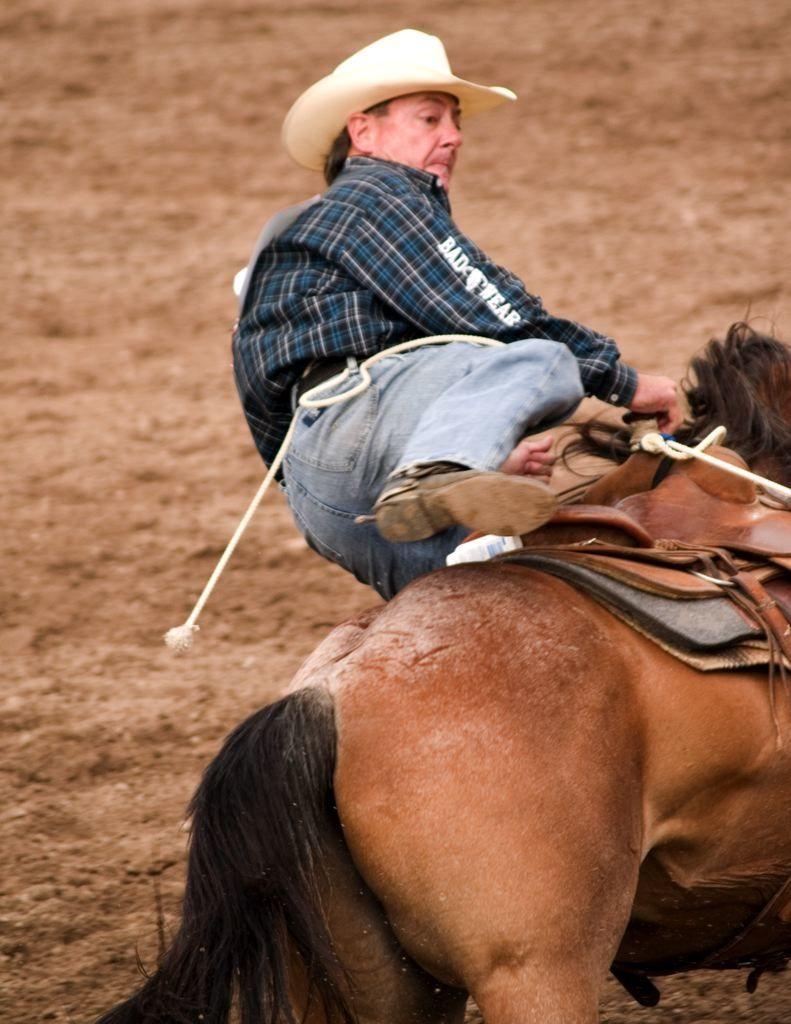What is present in the image? There is a man in the image. Can you describe what the man is wearing? The man is wearing a cap. What is the man holding in the image? The man is holding thread. What action is the man performing in the image? The man is falling from a horse. What is the result of the man falling in the image? The man lands on the ground. What type of gate can be seen in the image? There is no gate present in the image. What is the man's income based on the image? There is no information about the man's income in the image. 